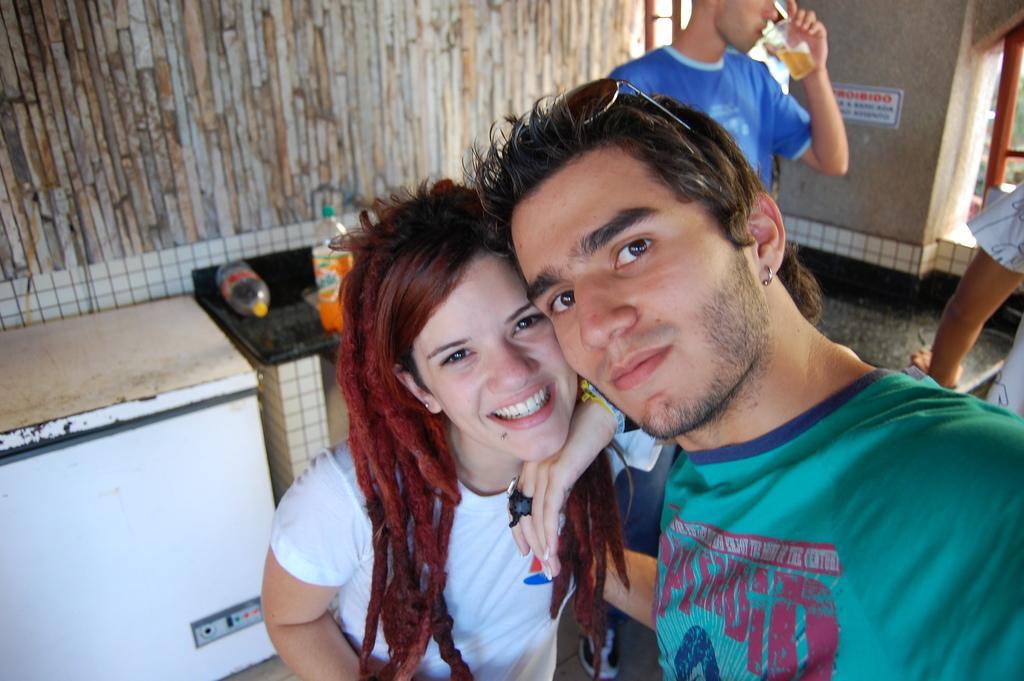Describe this image in one or two sentences. On the right side of this image I can see a man and a woman wearing t-shirts, smiling and giving pose for the picture. On the left side, I can see two tables on which two bottles are placed. In the background there are two persons standing. One person is holding a glass in the hand and drinking. At the top, I can see the wall. 